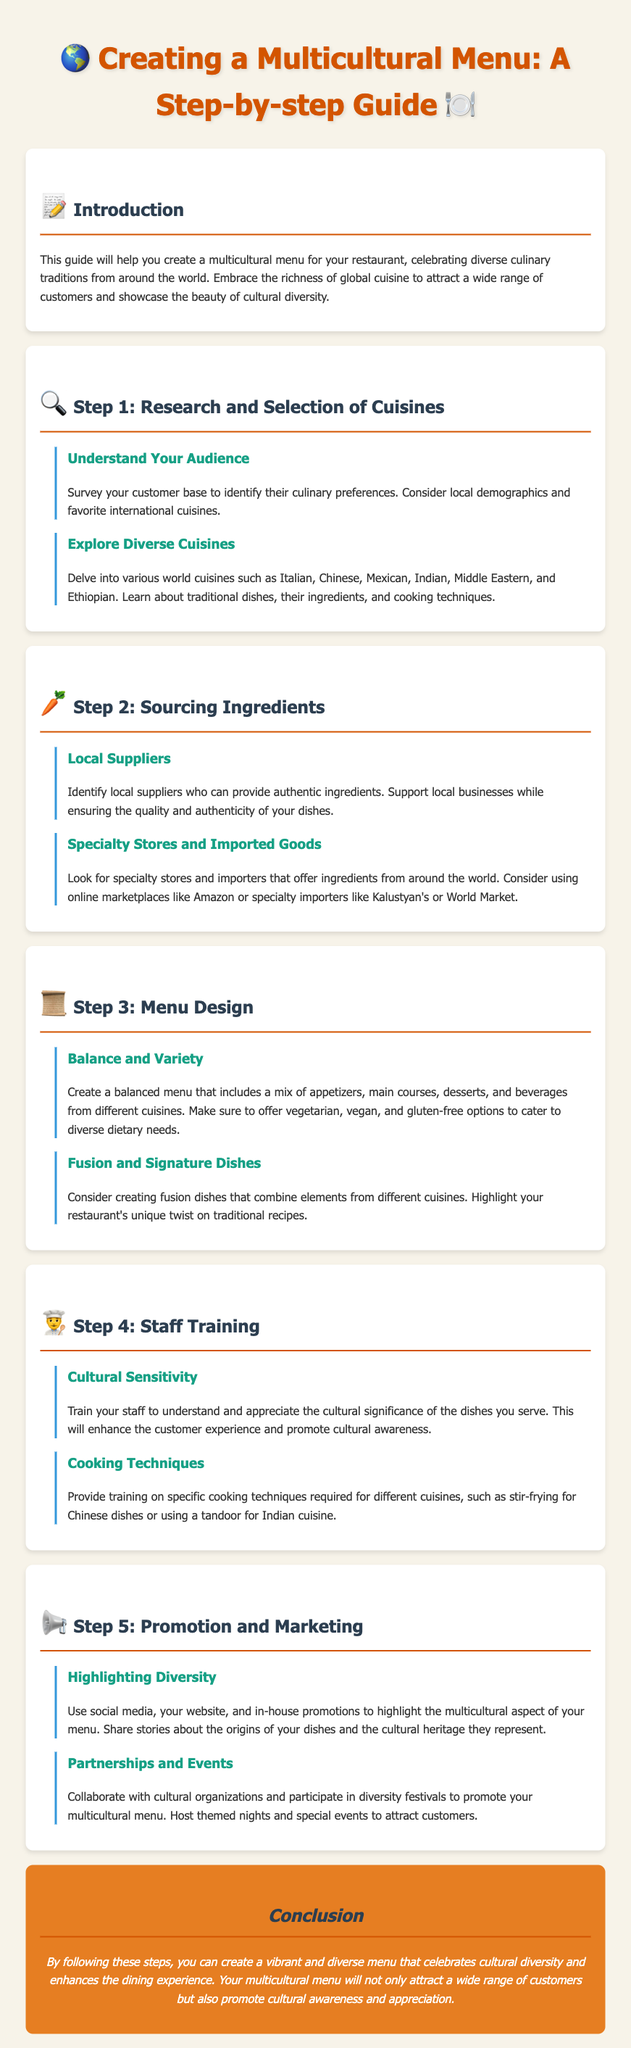what is the title of the guide? The title of the guide is stated at the beginning of the document.
Answer: Creating a Multicultural Menu: A Step-by-step Guide what is the main focus of the guide? The main focus of the guide is highlighted in the introduction section.
Answer: Creating a multicultural menu how many steps are outlined in the guide? The number of steps can be counted in the document.
Answer: Five what should be included in the menu design? The menu design section specifies types of dishes to include.
Answer: A mix of appetizers, main courses, desserts, and beverages what is the purpose of staff training? The reason for staff training is mentioned in the relevant section.
Answer: Understand and appreciate cultural significance which cuisines are suggested for exploration? The document lists several cuisines to explore in the research section.
Answer: Italian, Chinese, Mexican, Indian, Middle Eastern, and Ethiopian how can the multicultural aspect of the menu be promoted? Promotion and marketing strategies are provided in the guide.
Answer: Use social media, your website, and in-house promotions what is one benefit of a multicultural menu? Conclusion of the guide summarizes the advantage of having such a menu.
Answer: Attract a wide range of customers what type of dishes should fusion options include? The fusion dishes section implies what should be included.
Answer: Elements from different cuisines 